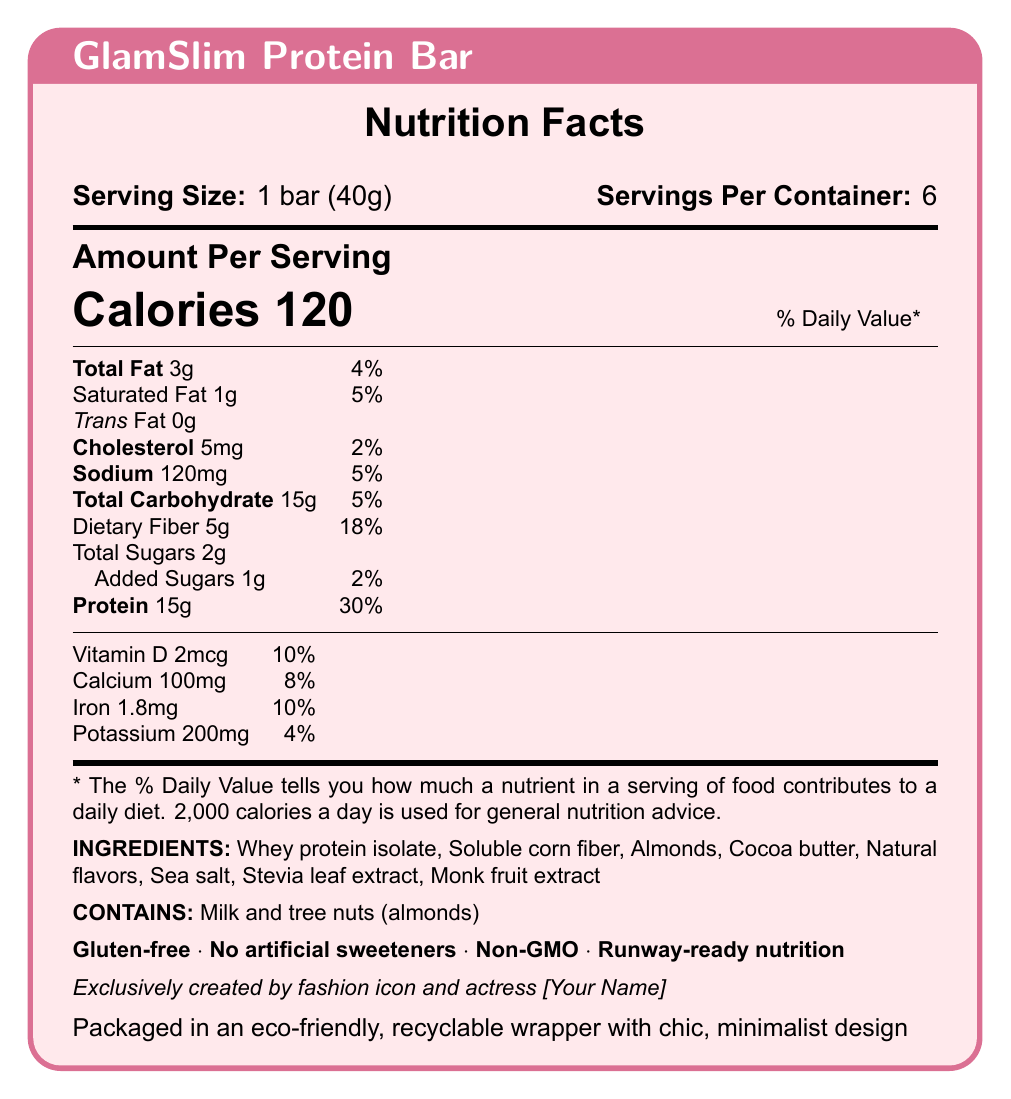what is the serving size of the GlamSlim Protein Bar? The document states that the serving size of the GlamSlim Protein Bar is 1 bar, which weighs 40 grams.
Answer: 1 bar (40g) how many servings are there per container? The document specifies that there are 6 servings per container.
Answer: 6 how many calories are in one serving of the GlamSlim Protein Bar? The document indicates that one serving of the GlamSlim Protein Bar contains 120 calories.
Answer: 120 what is the amount of protein per serving, and its daily value percentage? The document shows that each serving contains 15 grams of protein, which is 30% of the daily value.
Answer: 15g, 30% what allergens are present in the GlamSlim Protein Bar? The document specifies that the bar contains milk and tree nuts (almonds).
Answer: Milk and tree nuts (almonds) which of the following ingredients is not in the GlamSlim Protein Bar? A. Almonds B. Honey C. Stevia leaf extract D. Cocoa butter The list of ingredients in the document does not include honey, but it does include almonds, stevia leaf extract, and cocoa butter.
Answer: B. Honey what are the marketing claims associated with the GlamSlim Protein Bar? A. Gluten-free B. No artificial sweeteners C. Non-GMO D. All of the above The document lists all these claims as part of the marketing for the GlamSlim Protein Bar: Gluten-free, No artificial sweeteners, Non-GMO.
Answer: D. All of the above does the GlamSlim Protein Bar contain trans fat? The document states that the trans fat content is 0g, which means it does not contain trans fat.
Answer: No summarize the main idea of the document The concise summary provides an overview of the key attributes of the GlamSlim Protein Bar, including its nutritional contents, marketing claims, and eco-friendly packaging.
Answer: The GlamSlim Protein Bar is a low-calorie, high-protein snack designed for fashion-conscious dieters, offering 120 calories and 15 grams of protein per serving. It is gluten-free, non-GMO, and contains no artificial sweeteners. Each bar is designed with eco-friendly packaging and marketed with various health benefits. what is the amount of dietary fiber per serving, and its daily value percentage? The document indicates that each serving contains 5 grams of dietary fiber, which is 18% of the daily value.
Answer: 5g, 18% how much vitamin D is in each serving of the GlamSlim Protein Bar? The document states that each serving contains 2 micrograms of vitamin D.
Answer: 2mcg is the GlamSlim Protein Bar endorsed by any celebrity? The document mentions that the product is exclusively created by a fashion icon and actress, whose name can be filled in as desired.
Answer: Yes, exclusively created by fashion icon and actress [Your Name] can the amount of sugar alcohols in the GlamSlim Protein Bar be determined from the document? The document does not provide any information regarding the amount of sugar alcohols in the GlamSlim Protein Bar.
Answer: Cannot be determined 